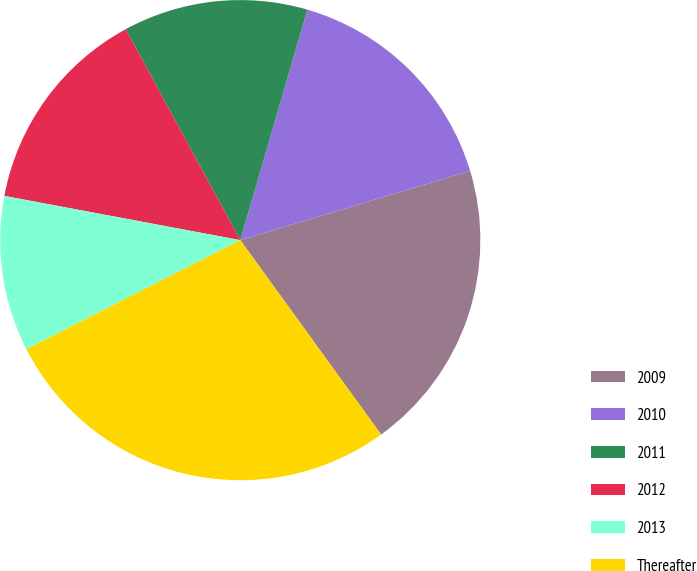<chart> <loc_0><loc_0><loc_500><loc_500><pie_chart><fcel>2009<fcel>2010<fcel>2011<fcel>2012<fcel>2013<fcel>Thereafter<nl><fcel>19.68%<fcel>15.83%<fcel>12.43%<fcel>14.13%<fcel>10.46%<fcel>27.47%<nl></chart> 